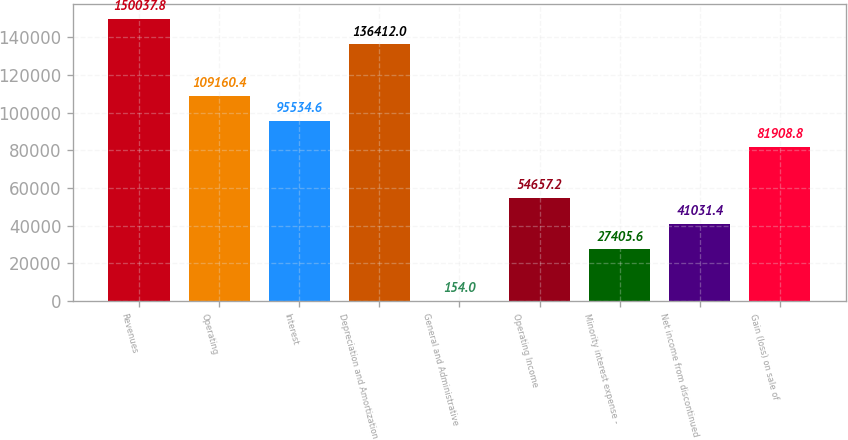Convert chart to OTSL. <chart><loc_0><loc_0><loc_500><loc_500><bar_chart><fcel>Revenues<fcel>Operating<fcel>Interest<fcel>Depreciation and Amortization<fcel>General and Administrative<fcel>Operating Income<fcel>Minority interest expense -<fcel>Net income from discontinued<fcel>Gain (loss) on sale of<nl><fcel>150038<fcel>109160<fcel>95534.6<fcel>136412<fcel>154<fcel>54657.2<fcel>27405.6<fcel>41031.4<fcel>81908.8<nl></chart> 